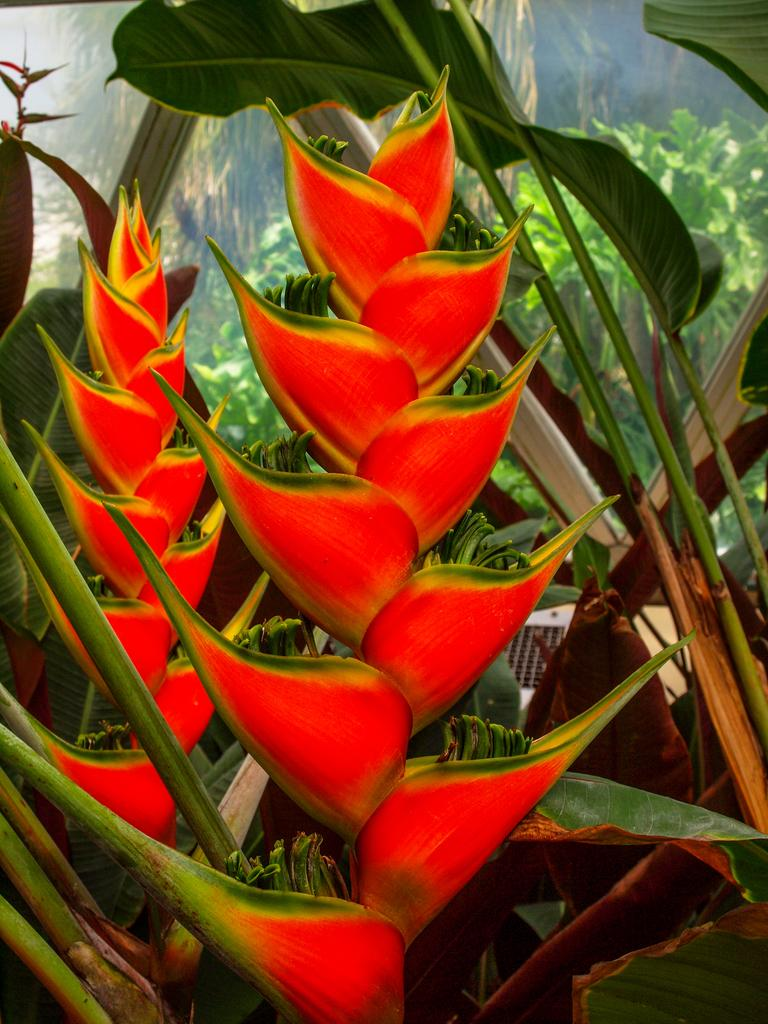What color are the steps in the image? The steps in the image are red. What can be found beside the steps? There is a flower beside the steps. What else is present in the image besides the steps and the flower? There are many plants in the image. How does the temper of the plants affect their growth in the image? The image does not provide information about the temper of the plants, so it cannot be determined how it affects their growth. 